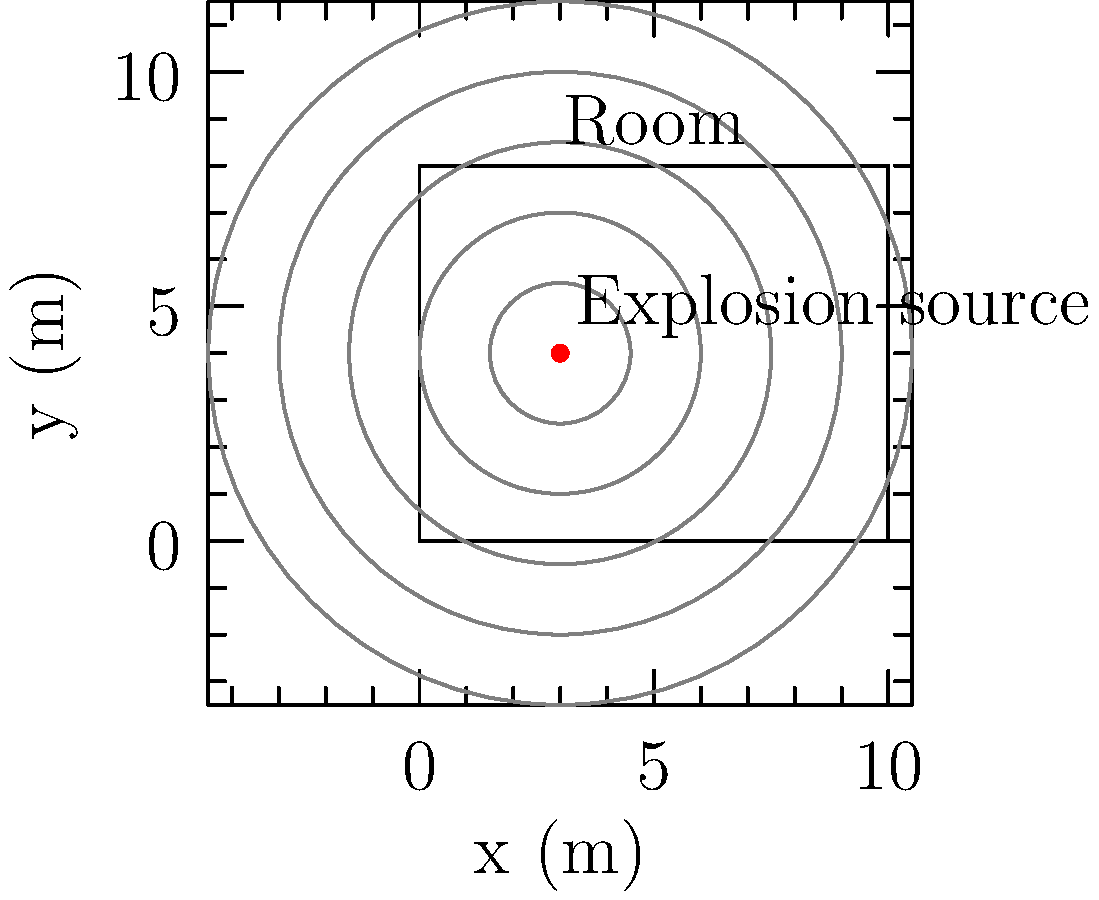In a rectangular room measuring 10m x 8m, an explosion occurs at coordinates (3m, 4m). Considering the psychological impact on individuals in the room, how does the sound wave propagation in this enclosed space differ from an open environment, and what factors contribute to potential heightened stress responses? To understand the sound wave propagation in this scenario and its psychological impact:

1. Initial wave propagation:
   - The explosion generates a spherical sound wave from the point source (3m, 4m).
   - In an open environment, this wave would propagate outward, decreasing in intensity with distance according to the inverse square law: $I \propto \frac{1}{r^2}$.

2. Enclosed space effects:
   - In the room, the sound waves reflect off walls, floor, and ceiling.
   - This creates a complex pattern of interfering waves, leading to:
     a) Standing waves: $f_n = \frac{n v}{2L}$, where $n$ is an integer, $v$ is wave velocity, and $L$ is room dimension.
     b) Resonance: amplification of certain frequencies.

3. Reverberation:
   - Multiple reflections cause sound to persist longer than in an open space.
   - Reverberation time (RT60) depends on room size and material absorption coefficients.

4. Pressure changes:
   - The explosion causes rapid air pressure changes.
   - In an enclosed space, these pressure changes can be more intense and last longer.

5. Psychological impacts:
   a) Increased perceived loudness due to reflections and reverberation.
   b) Disorientation from multiple sound sources (reflections).
   c) Prolonged exposure to the sound, potentially increasing stress and anxiety.
   d) Physical discomfort from rapid pressure changes.

6. Factors contributing to heightened stress:
   a) Inability to locate the exact source of the explosion.
   b) Potential for secondary explosions or structural damage.
   c) Difficulty in communication due to intense sound levels.
   d) Sensory overload from complex sound field.

7. Counterterrorism considerations:
   - Understanding these effects is crucial for:
     a) Designing safer structures.
     b) Developing effective evacuation protocols.
     c) Training first responders to manage both physical and psychological impacts.
Answer: Enclosed space intensifies sound through reflections and reverberation, potentially increasing psychological stress due to prolonged exposure, disorientation, and sensory overload. 